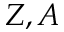Convert formula to latex. <formula><loc_0><loc_0><loc_500><loc_500>Z , A</formula> 